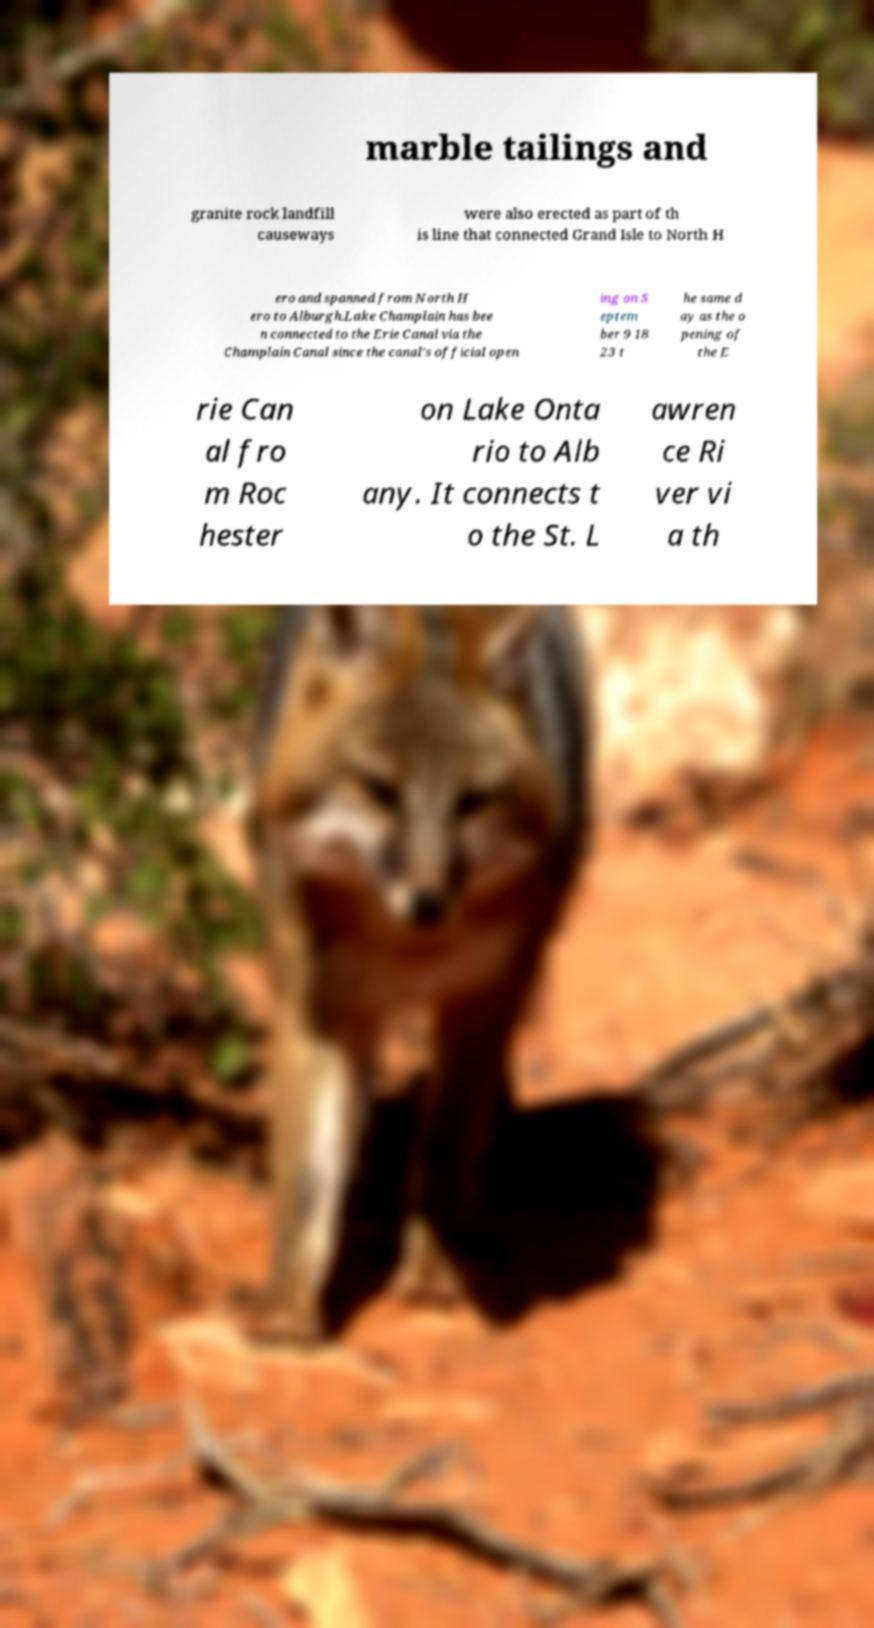Could you extract and type out the text from this image? marble tailings and granite rock landfill causeways were also erected as part of th is line that connected Grand Isle to North H ero and spanned from North H ero to Alburgh.Lake Champlain has bee n connected to the Erie Canal via the Champlain Canal since the canal's official open ing on S eptem ber 9 18 23 t he same d ay as the o pening of the E rie Can al fro m Roc hester on Lake Onta rio to Alb any. It connects t o the St. L awren ce Ri ver vi a th 